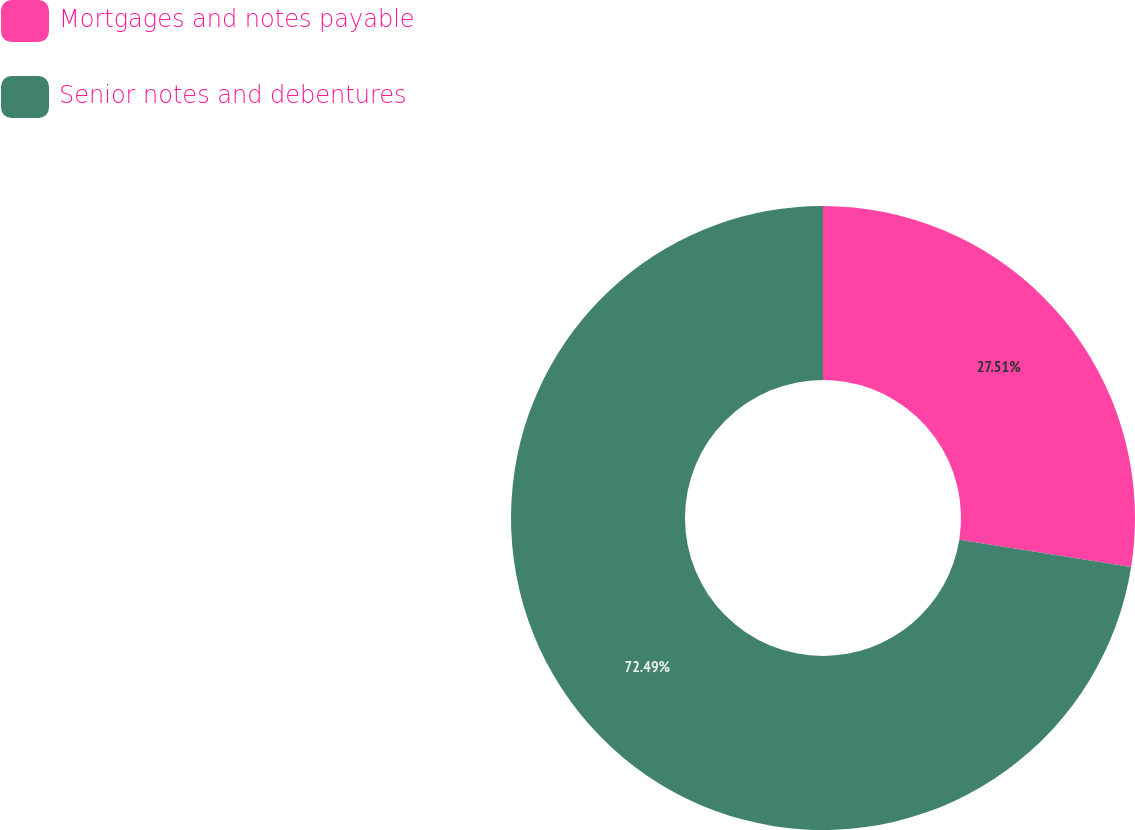<chart> <loc_0><loc_0><loc_500><loc_500><pie_chart><fcel>Mortgages and notes payable<fcel>Senior notes and debentures<nl><fcel>27.51%<fcel>72.49%<nl></chart> 